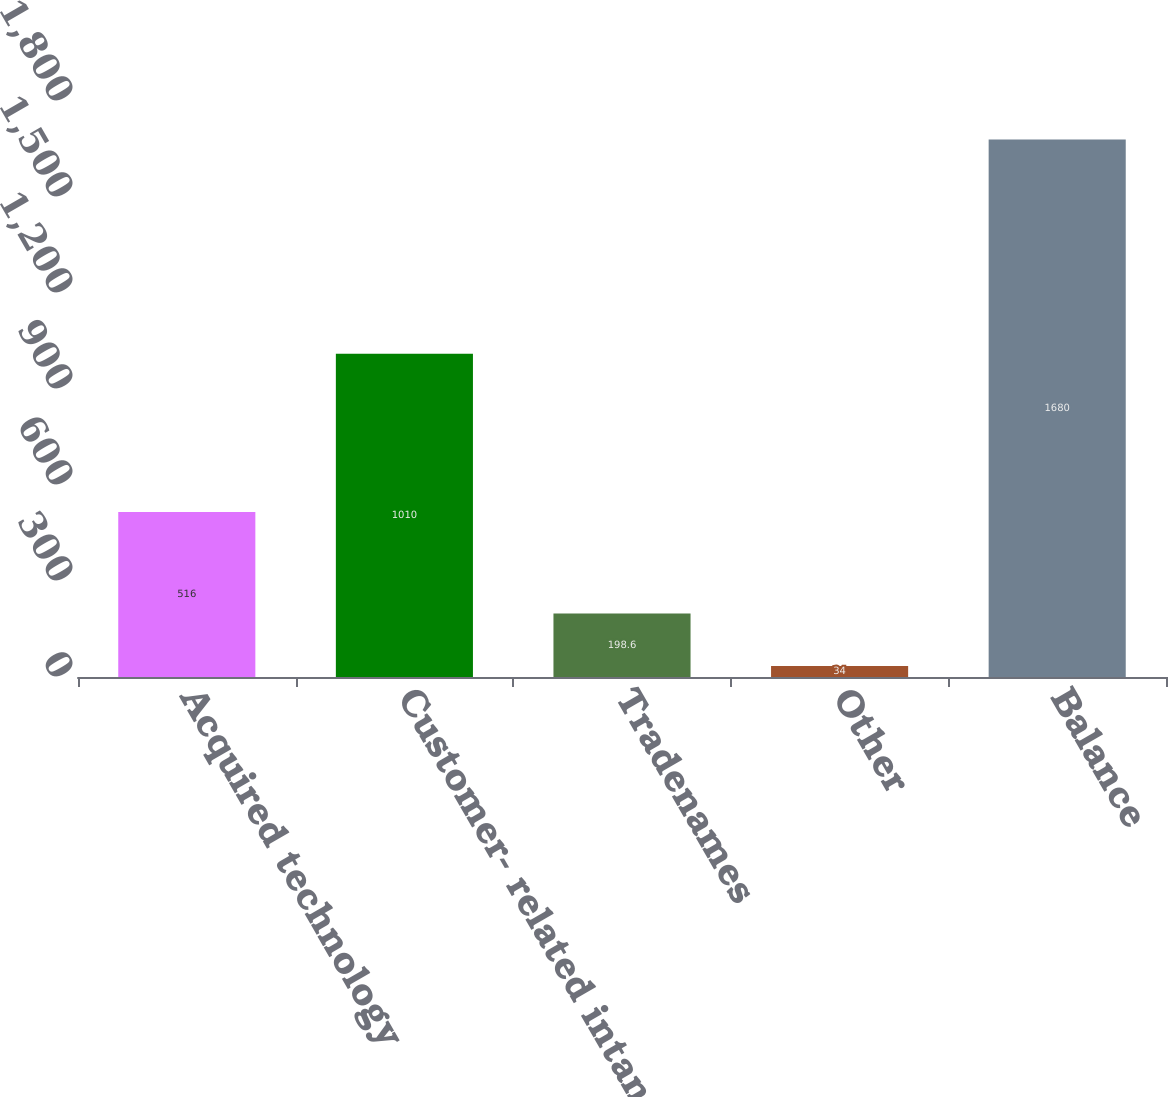<chart> <loc_0><loc_0><loc_500><loc_500><bar_chart><fcel>Acquired technology<fcel>Customer- related intangibles<fcel>Tradenames<fcel>Other<fcel>Balance<nl><fcel>516<fcel>1010<fcel>198.6<fcel>34<fcel>1680<nl></chart> 